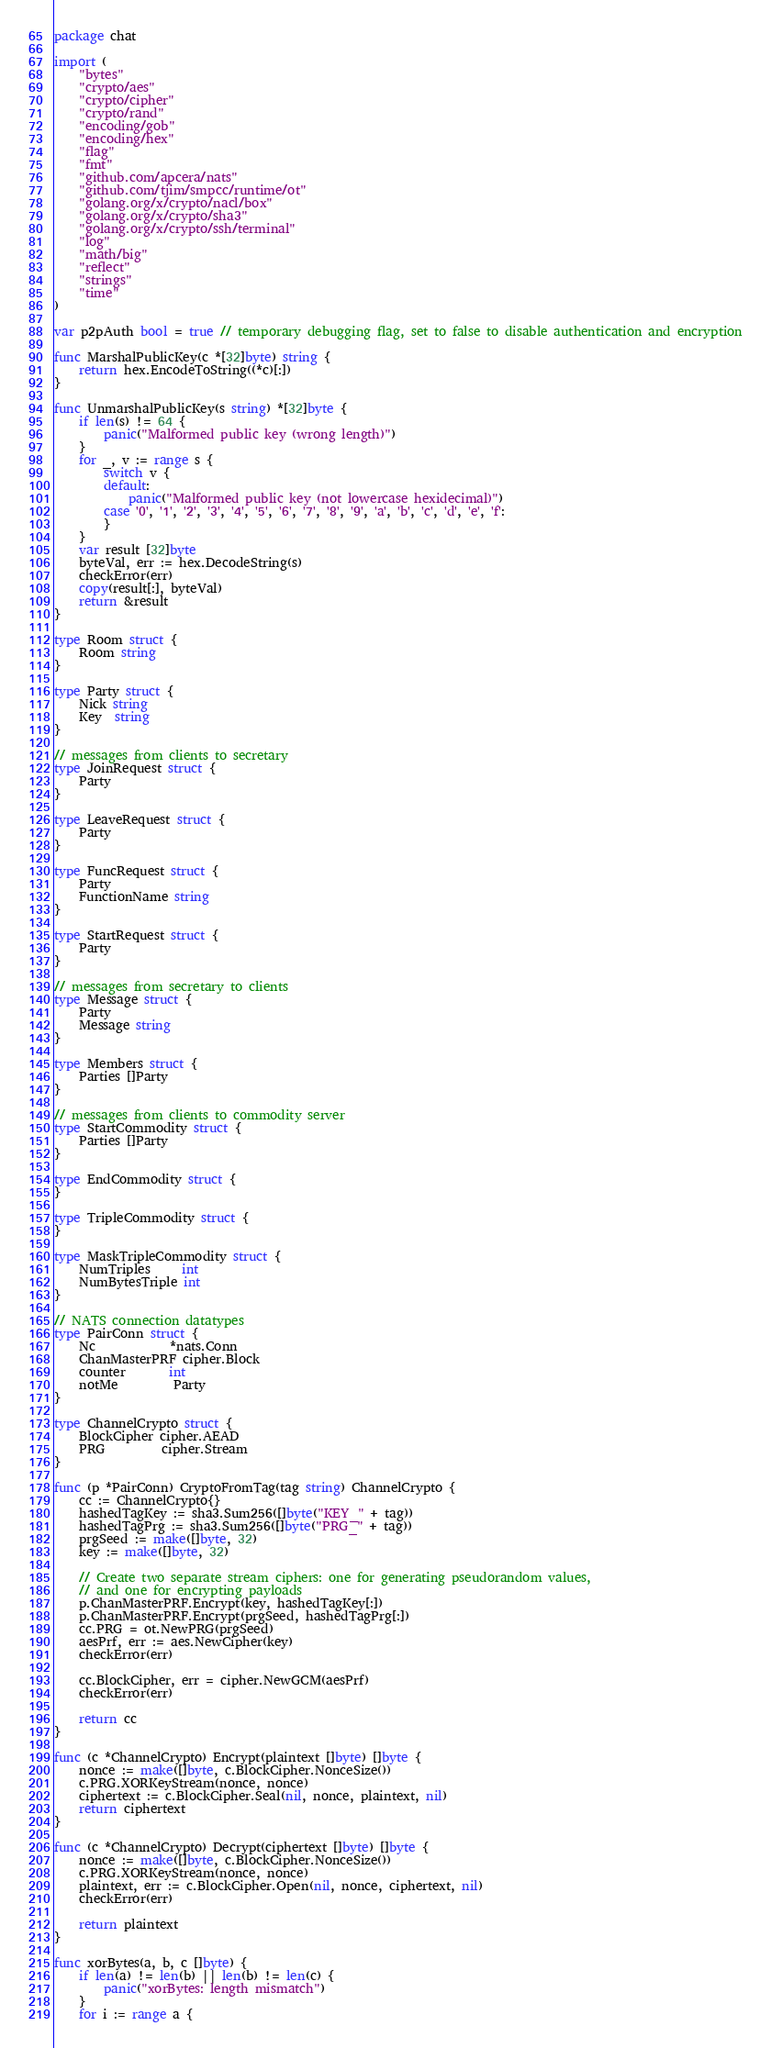<code> <loc_0><loc_0><loc_500><loc_500><_Go_>package chat

import (
	"bytes"
	"crypto/aes"
	"crypto/cipher"
	"crypto/rand"
	"encoding/gob"
	"encoding/hex"
	"flag"
	"fmt"
	"github.com/apcera/nats"
	"github.com/tjim/smpcc/runtime/ot"
	"golang.org/x/crypto/nacl/box"
	"golang.org/x/crypto/sha3"
	"golang.org/x/crypto/ssh/terminal"
	"log"
	"math/big"
	"reflect"
	"strings"
	"time"
)

var p2pAuth bool = true // temporary debugging flag, set to false to disable authentication and encryption

func MarshalPublicKey(c *[32]byte) string {
	return hex.EncodeToString((*c)[:])
}

func UnmarshalPublicKey(s string) *[32]byte {
	if len(s) != 64 {
		panic("Malformed public key (wrong length)")
	}
	for _, v := range s {
		switch v {
		default:
			panic("Malformed public key (not lowercase hexidecimal)")
		case '0', '1', '2', '3', '4', '5', '6', '7', '8', '9', 'a', 'b', 'c', 'd', 'e', 'f':
		}
	}
	var result [32]byte
	byteVal, err := hex.DecodeString(s)
	checkError(err)
	copy(result[:], byteVal)
	return &result
}

type Room struct {
	Room string
}

type Party struct {
	Nick string
	Key  string
}

// messages from clients to secretary
type JoinRequest struct {
	Party
}

type LeaveRequest struct {
	Party
}

type FuncRequest struct {
	Party
	FunctionName string
}

type StartRequest struct {
	Party
}

// messages from secretary to clients
type Message struct {
	Party
	Message string
}

type Members struct {
	Parties []Party
}

// messages from clients to commodity server
type StartCommodity struct {
	Parties []Party
}

type EndCommodity struct {
}

type TripleCommodity struct {
}

type MaskTripleCommodity struct {
	NumTriples     int
	NumBytesTriple int
}

// NATS connection datatypes
type PairConn struct {
	Nc            *nats.Conn
	ChanMasterPRF cipher.Block
	counter       int
	notMe         Party
}

type ChannelCrypto struct {
	BlockCipher cipher.AEAD
	PRG         cipher.Stream
}

func (p *PairConn) CryptoFromTag(tag string) ChannelCrypto {
	cc := ChannelCrypto{}
	hashedTagKey := sha3.Sum256([]byte("KEY_" + tag))
	hashedTagPrg := sha3.Sum256([]byte("PRG_" + tag))
	prgSeed := make([]byte, 32)
	key := make([]byte, 32)

	// Create two separate stream ciphers: one for generating pseudorandom values,
	// and one for encrypting payloads
	p.ChanMasterPRF.Encrypt(key, hashedTagKey[:])
	p.ChanMasterPRF.Encrypt(prgSeed, hashedTagPrg[:])
	cc.PRG = ot.NewPRG(prgSeed)
	aesPrf, err := aes.NewCipher(key)
	checkError(err)

	cc.BlockCipher, err = cipher.NewGCM(aesPrf)
	checkError(err)

	return cc
}

func (c *ChannelCrypto) Encrypt(plaintext []byte) []byte {
	nonce := make([]byte, c.BlockCipher.NonceSize())
	c.PRG.XORKeyStream(nonce, nonce)
	ciphertext := c.BlockCipher.Seal(nil, nonce, plaintext, nil)
	return ciphertext
}

func (c *ChannelCrypto) Decrypt(ciphertext []byte) []byte {
	nonce := make([]byte, c.BlockCipher.NonceSize())
	c.PRG.XORKeyStream(nonce, nonce)
	plaintext, err := c.BlockCipher.Open(nil, nonce, ciphertext, nil)
	checkError(err)

	return plaintext
}

func xorBytes(a, b, c []byte) {
	if len(a) != len(b) || len(b) != len(c) {
		panic("xorBytes: length mismatch")
	}
	for i := range a {</code> 